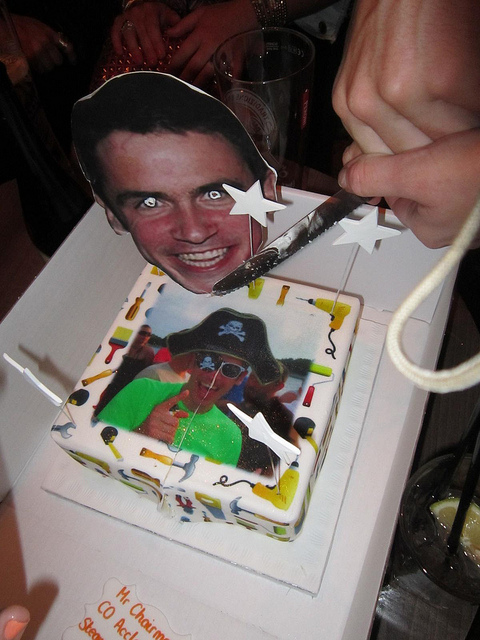<image>What famous cartoon character is on this cake? I am not sure about the famous cartoon character on the cake. It could be a pirate or some other character. What famous cartoon character is on this cake? I don't know what famous cartoon character is on this cake. It seems like there is no famous cartoon character on the cake. 